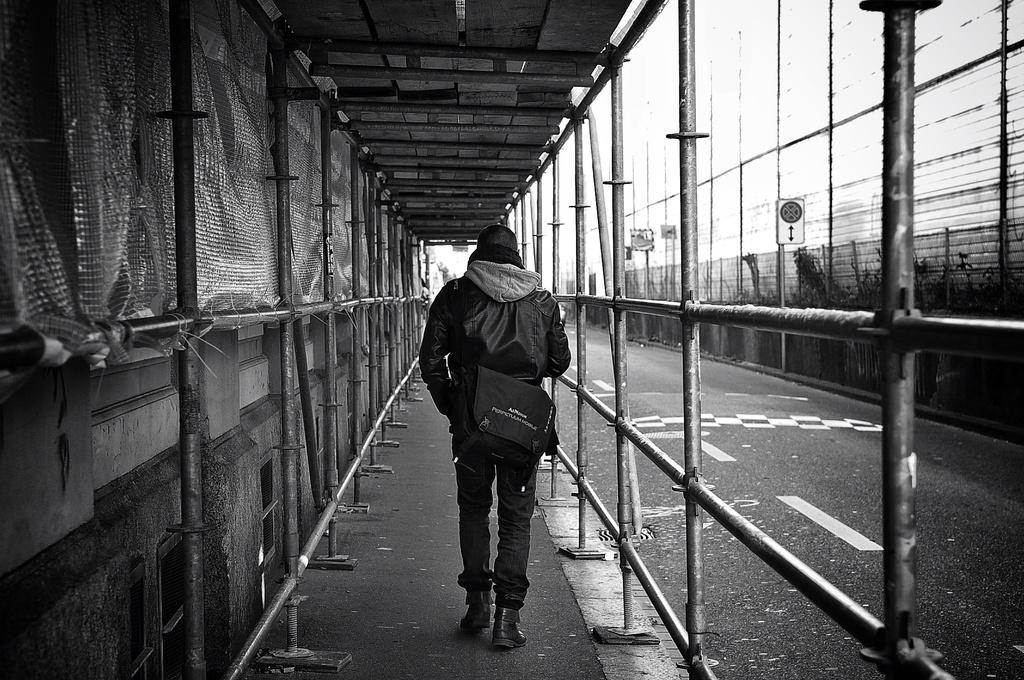What is the person in the image doing? The person is walking in the image. What is the person carrying while walking? The person is wearing a bag. What is located beside the person? There is a fencing beside the person. What can be seen in the image that provides information or directions? There are sign boards in the image. What type of natural elements are present in the image? There are plants in the image. How many boats can be seen in the image? There are no boats present in the image. Are the person's sisters also walking in the image? The provided facts do not mention any sisters, so we cannot determine if they are present in the image. 